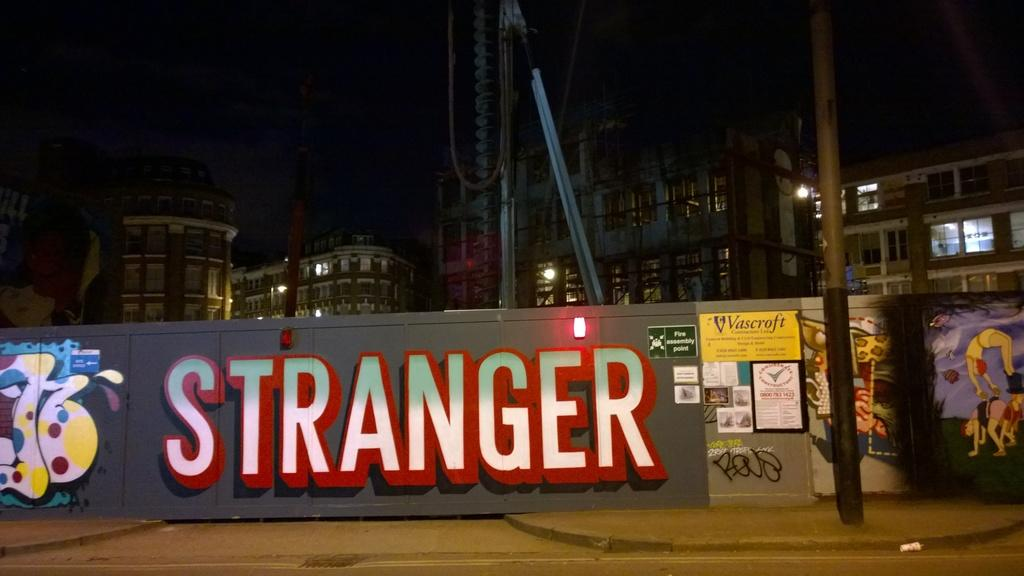What is present on the wall in the image? There is a painting on the wall in the image. What can be seen in the background of the image? Buildings are visible in the background of the image. How would you describe the lighting in the image? The image was captured at night, resulting in a dark background. What type of competition is taking place in the image? There is no competition present in the image; it features a painting on a wall with buildings in the background. Can you tell me the total cost of the items in the image based on the receipt? There is no receipt present in the image, as it features a painting on a wall and buildings in the background. 